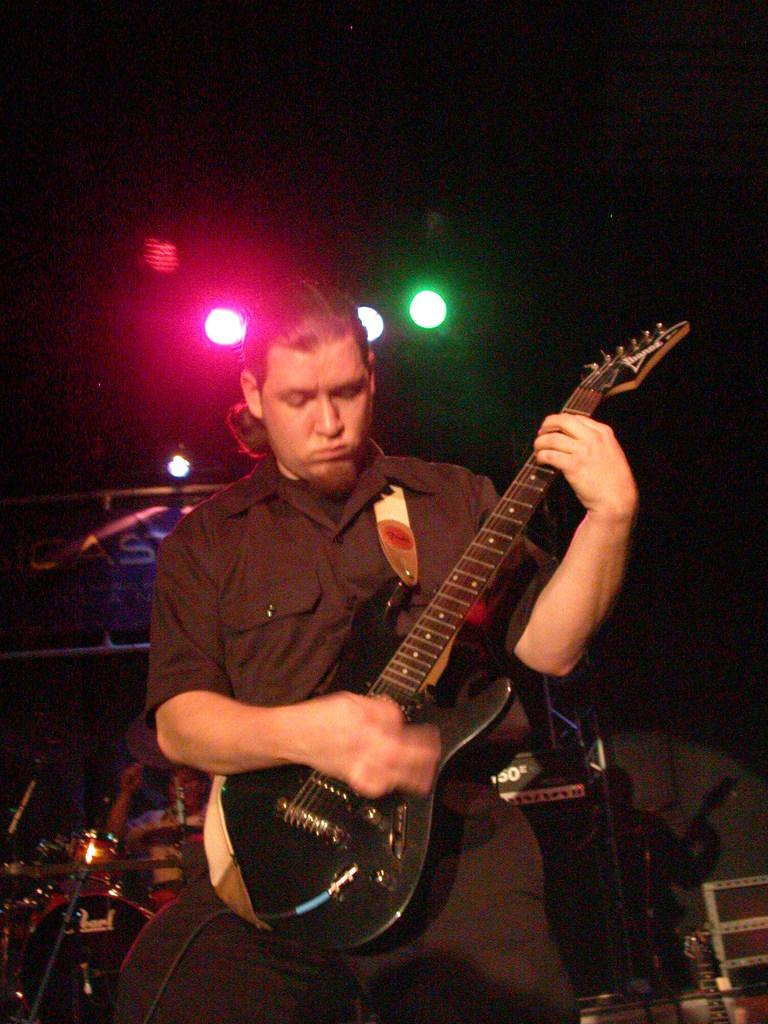What is the main subject of the image? There is a person in the image. What is the person wearing? The person is wearing a black dress. What activity is the person engaged in? The person is playing a guitar. What can be seen in the background of the image? There are lights visible in the background of the image. What type of hat is the person's dad wearing in the image? There is no dad or hat present in the image. 